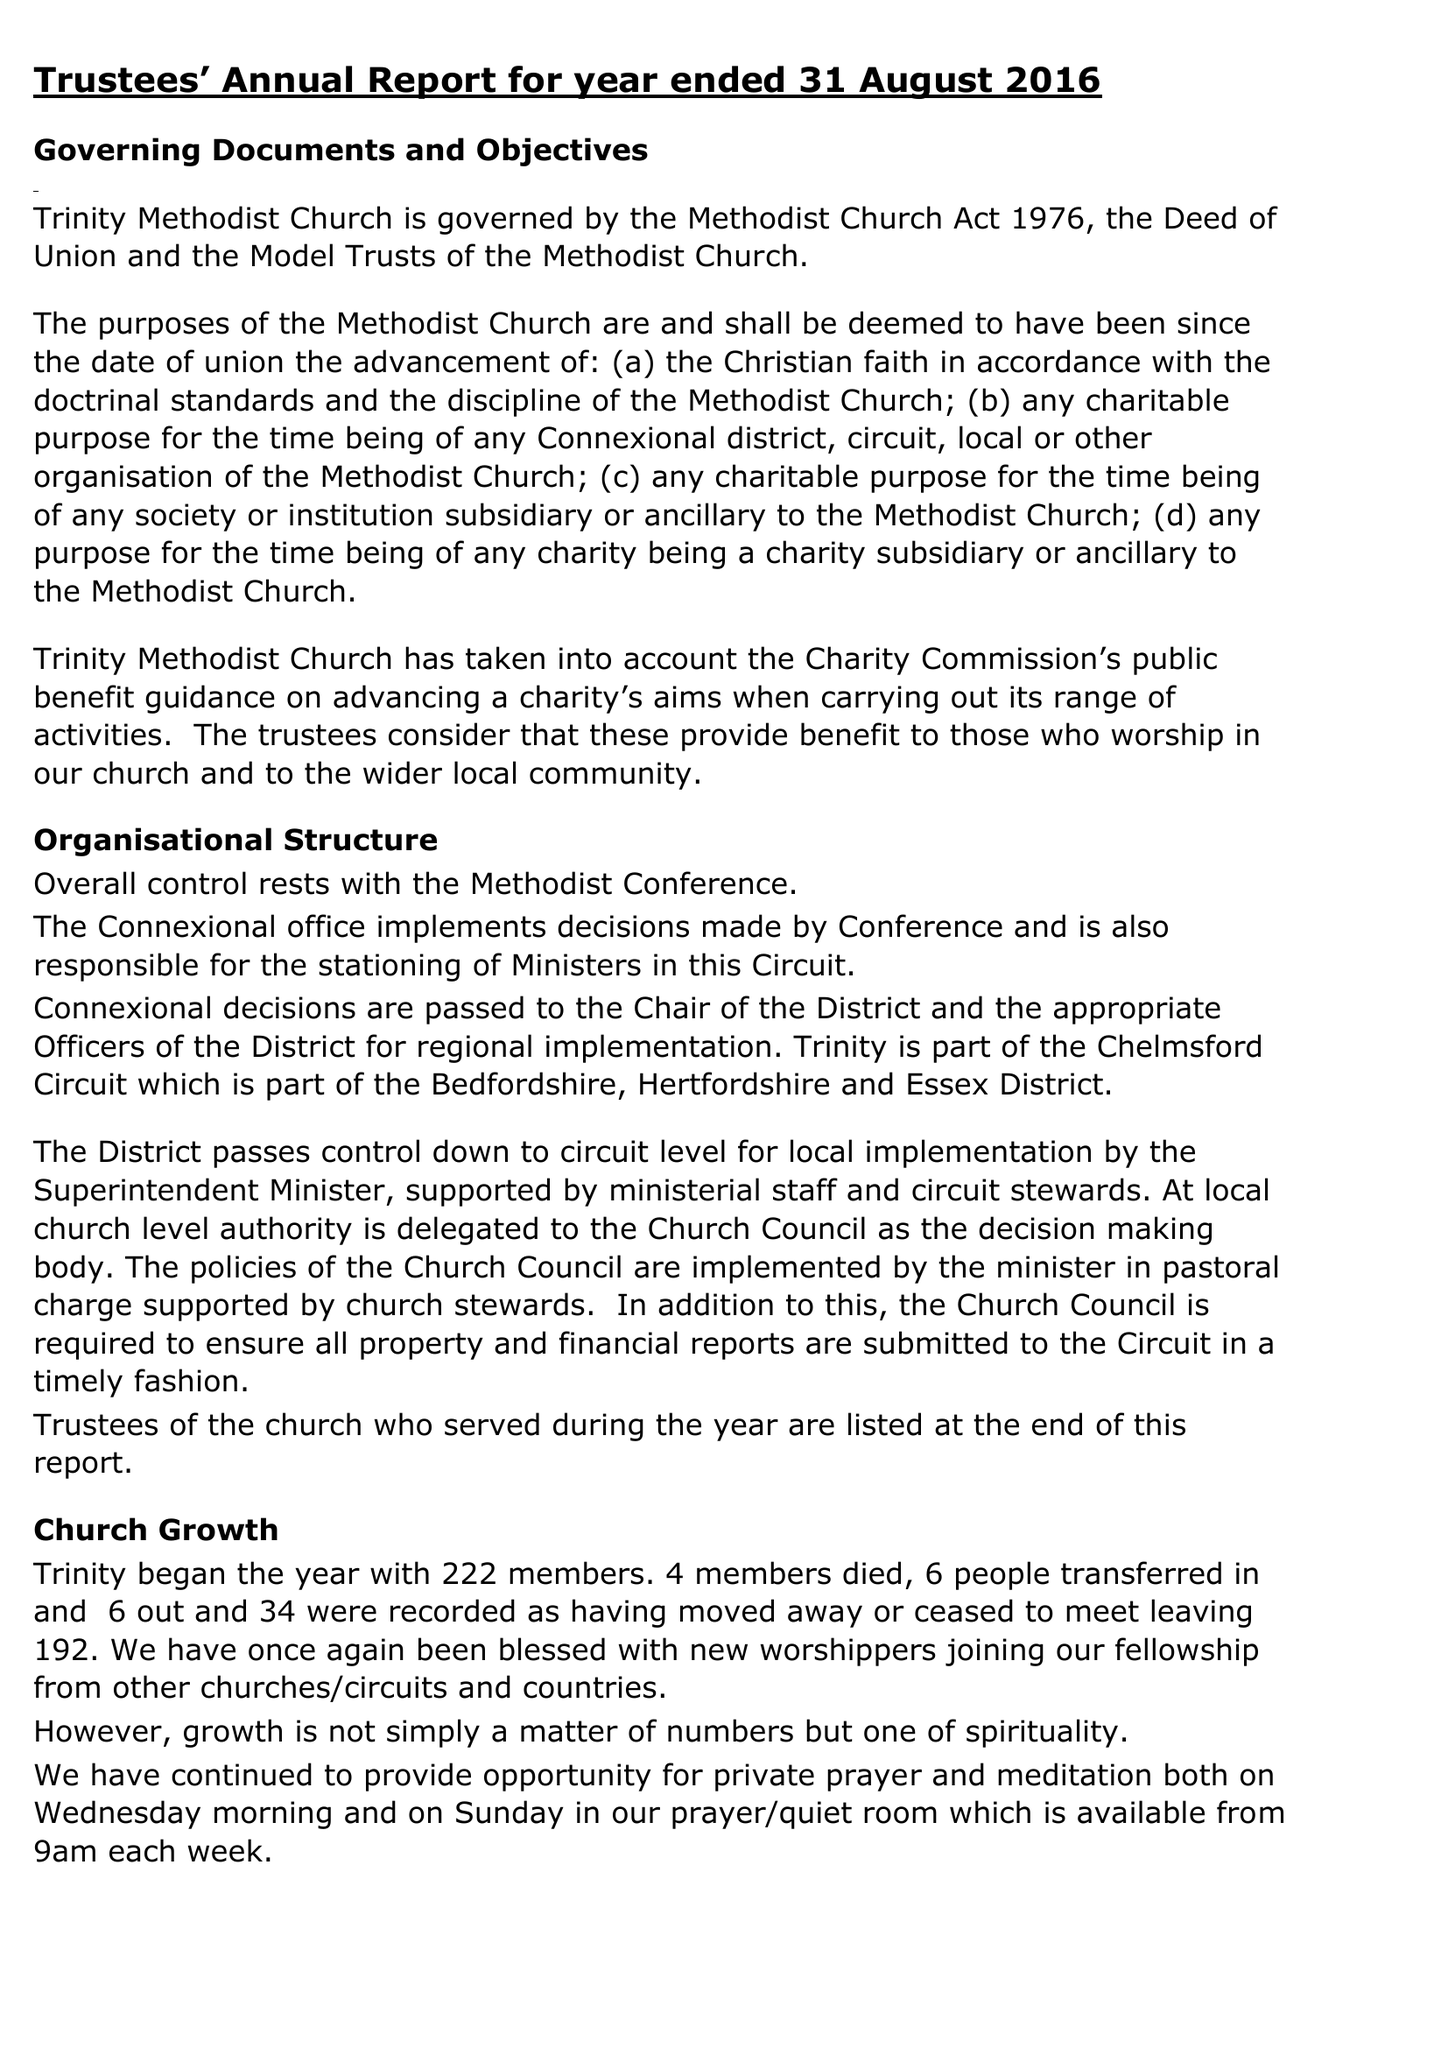What is the value for the address__postcode?
Answer the question using a single word or phrase. CM1 2AA 